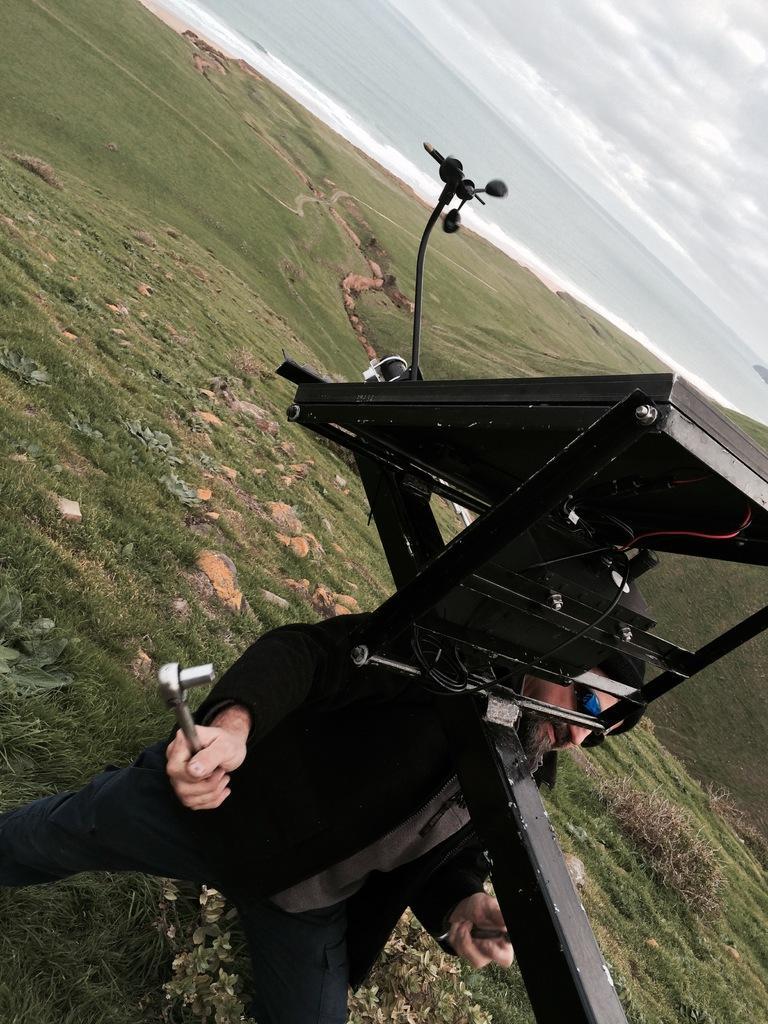How would you summarize this image in a sentence or two? In this image I can see the ground, some grass on the ground and a person wearing black color dress is standing and holding a metal object in his hand. I can see a black colored object and in the background I can see the water and the sky. 